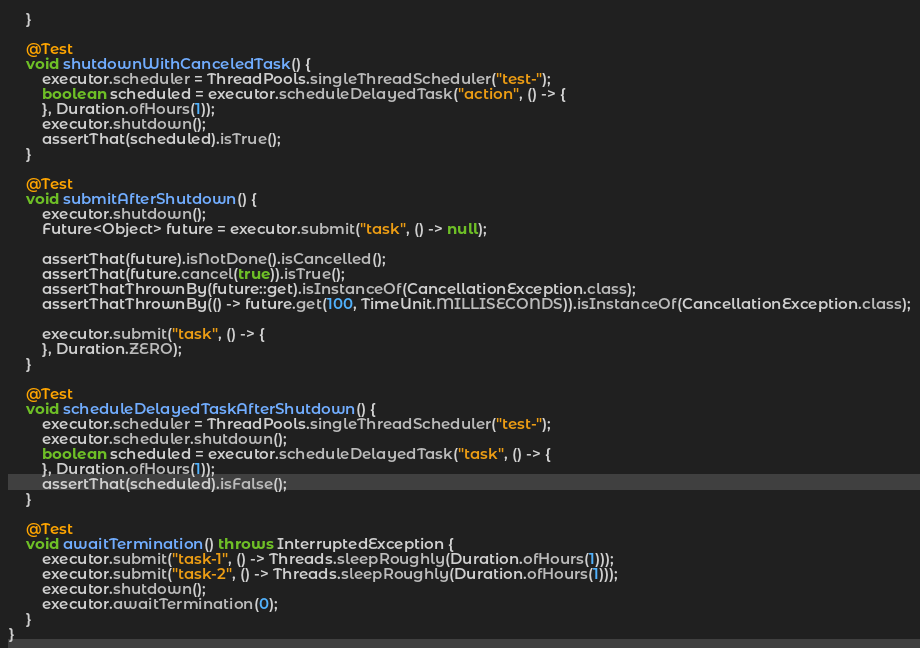<code> <loc_0><loc_0><loc_500><loc_500><_Java_>    }

    @Test
    void shutdownWithCanceledTask() {
        executor.scheduler = ThreadPools.singleThreadScheduler("test-");
        boolean scheduled = executor.scheduleDelayedTask("action", () -> {
        }, Duration.ofHours(1));
        executor.shutdown();
        assertThat(scheduled).isTrue();
    }

    @Test
    void submitAfterShutdown() {
        executor.shutdown();
        Future<Object> future = executor.submit("task", () -> null);

        assertThat(future).isNotDone().isCancelled();
        assertThat(future.cancel(true)).isTrue();
        assertThatThrownBy(future::get).isInstanceOf(CancellationException.class);
        assertThatThrownBy(() -> future.get(100, TimeUnit.MILLISECONDS)).isInstanceOf(CancellationException.class);

        executor.submit("task", () -> {
        }, Duration.ZERO);
    }

    @Test
    void scheduleDelayedTaskAfterShutdown() {
        executor.scheduler = ThreadPools.singleThreadScheduler("test-");
        executor.scheduler.shutdown();
        boolean scheduled = executor.scheduleDelayedTask("task", () -> {
        }, Duration.ofHours(1));
        assertThat(scheduled).isFalse();
    }

    @Test
    void awaitTermination() throws InterruptedException {
        executor.submit("task-1", () -> Threads.sleepRoughly(Duration.ofHours(1)));
        executor.submit("task-2", () -> Threads.sleepRoughly(Duration.ofHours(1)));
        executor.shutdown();
        executor.awaitTermination(0);
    }
}
</code> 